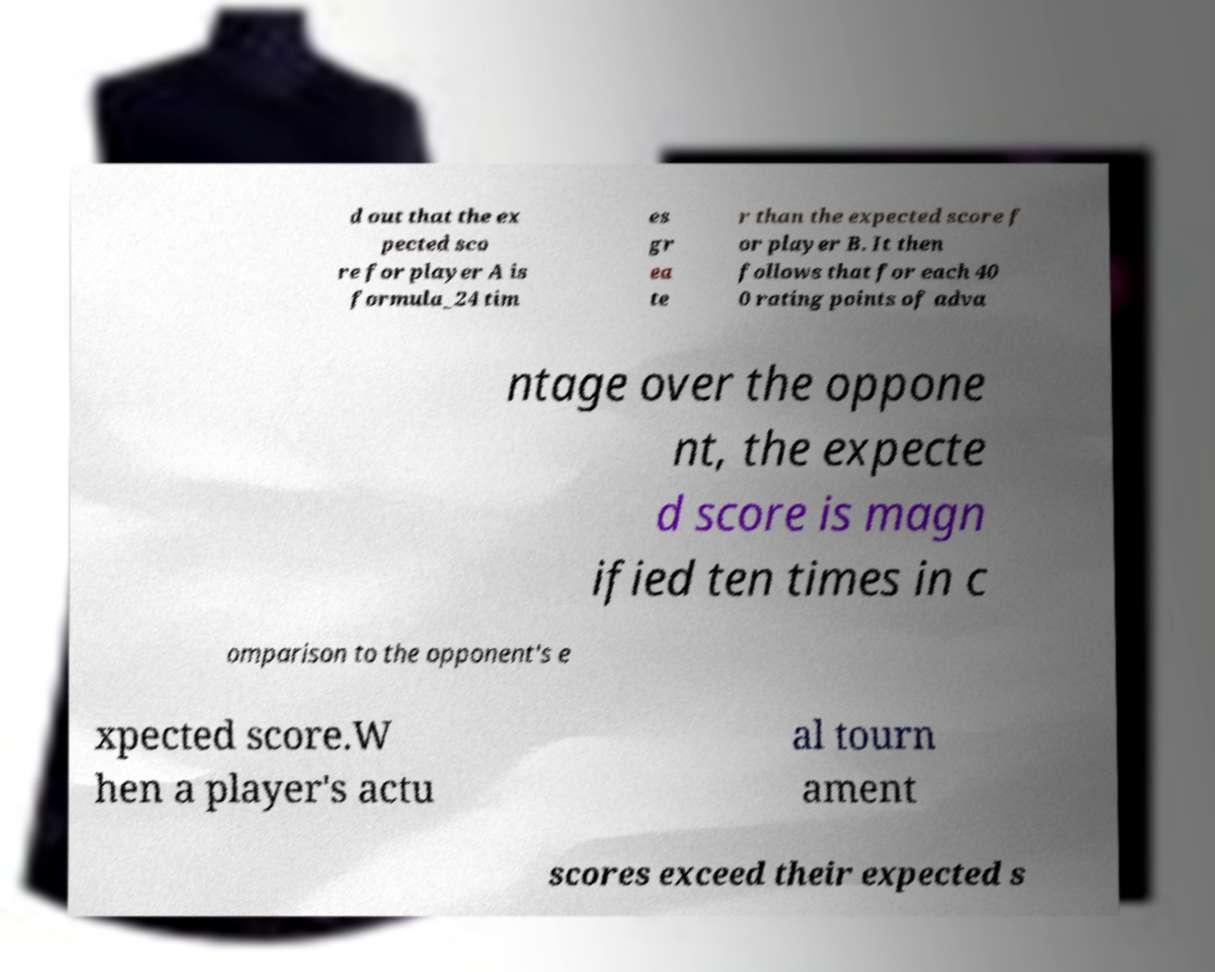Could you assist in decoding the text presented in this image and type it out clearly? d out that the ex pected sco re for player A is formula_24 tim es gr ea te r than the expected score f or player B. It then follows that for each 40 0 rating points of adva ntage over the oppone nt, the expecte d score is magn ified ten times in c omparison to the opponent's e xpected score.W hen a player's actu al tourn ament scores exceed their expected s 